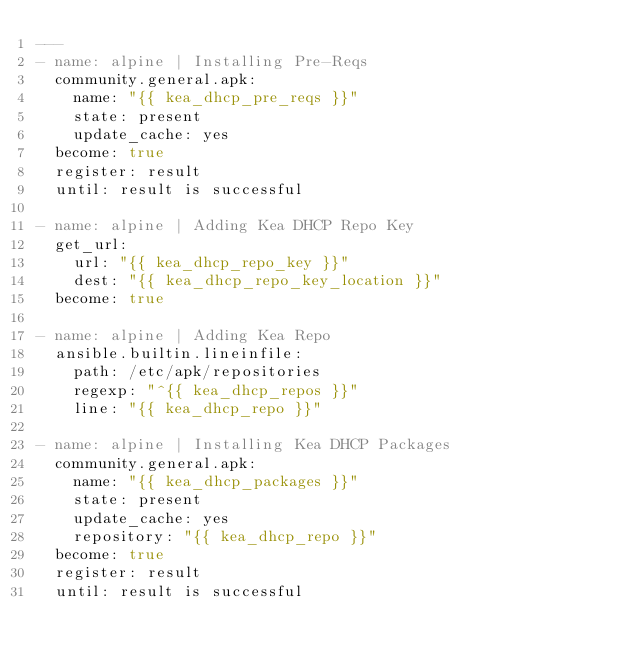Convert code to text. <code><loc_0><loc_0><loc_500><loc_500><_YAML_>---
- name: alpine | Installing Pre-Reqs
  community.general.apk:
    name: "{{ kea_dhcp_pre_reqs }}"
    state: present
    update_cache: yes
  become: true
  register: result
  until: result is successful

- name: alpine | Adding Kea DHCP Repo Key
  get_url:
    url: "{{ kea_dhcp_repo_key }}"
    dest: "{{ kea_dhcp_repo_key_location }}"
  become: true

- name: alpine | Adding Kea Repo
  ansible.builtin.lineinfile:
    path: /etc/apk/repositories
    regexp: "^{{ kea_dhcp_repos }}"
    line: "{{ kea_dhcp_repo }}"

- name: alpine | Installing Kea DHCP Packages
  community.general.apk:
    name: "{{ kea_dhcp_packages }}"
    state: present
    update_cache: yes
    repository: "{{ kea_dhcp_repo }}"
  become: true
  register: result
  until: result is successful
</code> 